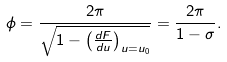Convert formula to latex. <formula><loc_0><loc_0><loc_500><loc_500>\phi = \frac { 2 \pi } { \sqrt { 1 - \left ( \frac { d F } { d u } \right ) _ { u = u _ { 0 } } } } = \frac { 2 \pi } { 1 - \sigma } .</formula> 